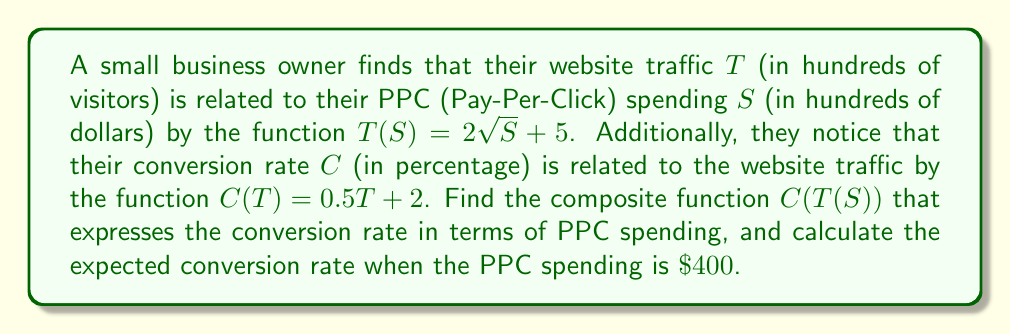What is the answer to this math problem? To solve this problem, we need to follow these steps:

1) First, let's identify the given functions:
   $T(S) = 2\sqrt{S} + 5$ (Traffic as a function of Spending)
   $C(T) = 0.5T + 2$ (Conversion rate as a function of Traffic)

2) To find the composite function $C(T(S))$, we need to substitute $T(S)$ into $C(T)$:

   $C(T(S)) = C(2\sqrt{S} + 5)$

3) Now, let's substitute this into the function $C(T)$:

   $C(T(S)) = 0.5(2\sqrt{S} + 5) + 2$

4) Simplify:
   $C(T(S)) = \sqrt{S} + 2.5 + 2$
   $C(T(S)) = \sqrt{S} + 4.5$

5) This is our composite function that expresses conversion rate in terms of PPC spending.

6) To calculate the expected conversion rate when PPC spending is $\$400$:
   First, note that $S$ is in hundreds of dollars, so $\$400 = 4$ in our function.

   $C(T(4)) = \sqrt{4} + 4.5$
            $= 2 + 4.5$
            $= 6.5$

Therefore, when PPC spending is $\$400$, the expected conversion rate is 6.5%.
Answer: The composite function is $C(T(S)) = \sqrt{S} + 4.5$, where $S$ is in hundreds of dollars and $C$ is in percentage. When PPC spending is $\$400$, the expected conversion rate is 6.5%. 